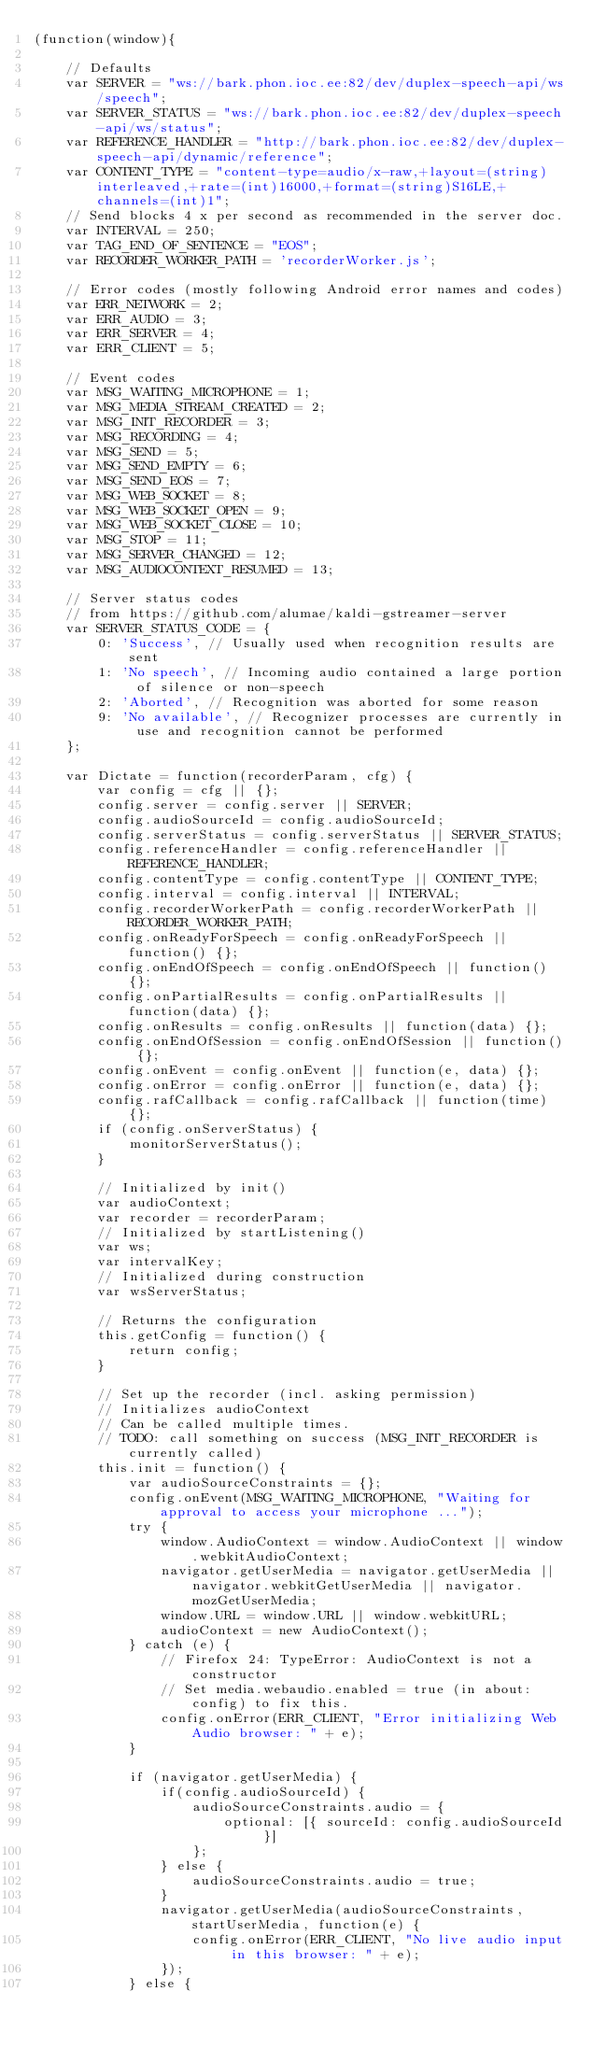Convert code to text. <code><loc_0><loc_0><loc_500><loc_500><_JavaScript_>(function(window){

	// Defaults
	var SERVER = "ws://bark.phon.ioc.ee:82/dev/duplex-speech-api/ws/speech";
	var SERVER_STATUS = "ws://bark.phon.ioc.ee:82/dev/duplex-speech-api/ws/status";
	var REFERENCE_HANDLER = "http://bark.phon.ioc.ee:82/dev/duplex-speech-api/dynamic/reference";
	var CONTENT_TYPE = "content-type=audio/x-raw,+layout=(string)interleaved,+rate=(int)16000,+format=(string)S16LE,+channels=(int)1";
	// Send blocks 4 x per second as recommended in the server doc.
	var INTERVAL = 250;
	var TAG_END_OF_SENTENCE = "EOS";
	var RECORDER_WORKER_PATH = 'recorderWorker.js';

	// Error codes (mostly following Android error names and codes)
	var ERR_NETWORK = 2;
	var ERR_AUDIO = 3;
	var ERR_SERVER = 4;
	var ERR_CLIENT = 5;

	// Event codes
	var MSG_WAITING_MICROPHONE = 1;
	var MSG_MEDIA_STREAM_CREATED = 2;
	var MSG_INIT_RECORDER = 3;
	var MSG_RECORDING = 4;
	var MSG_SEND = 5;
	var MSG_SEND_EMPTY = 6;
	var MSG_SEND_EOS = 7;
	var MSG_WEB_SOCKET = 8;
	var MSG_WEB_SOCKET_OPEN = 9;
	var MSG_WEB_SOCKET_CLOSE = 10;
	var MSG_STOP = 11;
	var MSG_SERVER_CHANGED = 12;
	var MSG_AUDIOCONTEXT_RESUMED = 13;

	// Server status codes
	// from https://github.com/alumae/kaldi-gstreamer-server
	var SERVER_STATUS_CODE = {
		0: 'Success', // Usually used when recognition results are sent
		1: 'No speech', // Incoming audio contained a large portion of silence or non-speech
		2: 'Aborted', // Recognition was aborted for some reason
		9: 'No available', // Recognizer processes are currently in use and recognition cannot be performed
	};

	var Dictate = function(recorderParam, cfg) {
		var config = cfg || {};
		config.server = config.server || SERVER;
		config.audioSourceId = config.audioSourceId;
		config.serverStatus = config.serverStatus || SERVER_STATUS;
		config.referenceHandler = config.referenceHandler || REFERENCE_HANDLER;
		config.contentType = config.contentType || CONTENT_TYPE;
		config.interval = config.interval || INTERVAL;
		config.recorderWorkerPath = config.recorderWorkerPath || RECORDER_WORKER_PATH;
		config.onReadyForSpeech = config.onReadyForSpeech || function() {};
		config.onEndOfSpeech = config.onEndOfSpeech || function() {};
		config.onPartialResults = config.onPartialResults || function(data) {};
		config.onResults = config.onResults || function(data) {};
		config.onEndOfSession = config.onEndOfSession || function() {};
		config.onEvent = config.onEvent || function(e, data) {};
		config.onError = config.onError || function(e, data) {};
		config.rafCallback = config.rafCallback || function(time) {};
		if (config.onServerStatus) {
			monitorServerStatus();
		}

		// Initialized by init()
		var audioContext;
		var recorder = recorderParam;
		// Initialized by startListening()
		var ws;
		var intervalKey;
		// Initialized during construction
		var wsServerStatus;

		// Returns the configuration
		this.getConfig = function() {
			return config;
		}

		// Set up the recorder (incl. asking permission)
		// Initializes audioContext
		// Can be called multiple times.
		// TODO: call something on success (MSG_INIT_RECORDER is currently called)
		this.init = function() {
			var audioSourceConstraints = {};
			config.onEvent(MSG_WAITING_MICROPHONE, "Waiting for approval to access your microphone ...");
			try {
				window.AudioContext = window.AudioContext || window.webkitAudioContext;
				navigator.getUserMedia = navigator.getUserMedia || navigator.webkitGetUserMedia || navigator.mozGetUserMedia;
				window.URL = window.URL || window.webkitURL;
				audioContext = new AudioContext();
			} catch (e) {
				// Firefox 24: TypeError: AudioContext is not a constructor
				// Set media.webaudio.enabled = true (in about:config) to fix this.
				config.onError(ERR_CLIENT, "Error initializing Web Audio browser: " + e);
			}

			if (navigator.getUserMedia) {
				if(config.audioSourceId) {
					audioSourceConstraints.audio = {
						optional: [{ sourceId: config.audioSourceId }]
					};
				} else {
					audioSourceConstraints.audio = true;
				}
				navigator.getUserMedia(audioSourceConstraints, startUserMedia, function(e) {
					config.onError(ERR_CLIENT, "No live audio input in this browser: " + e);
				});
			} else {</code> 